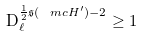<formula> <loc_0><loc_0><loc_500><loc_500>\mathrm D _ { \ell } ^ { \frac { 1 } { 2 } \mathfrak s ( \ m c H ^ { \prime } ) - 2 } \geq 1</formula> 